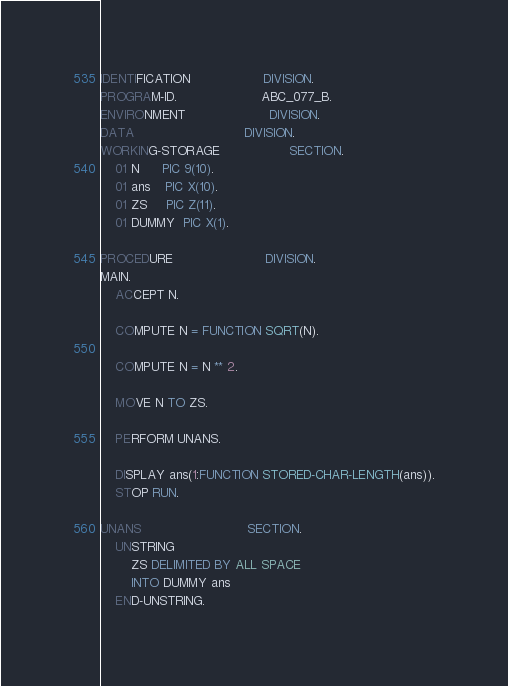<code> <loc_0><loc_0><loc_500><loc_500><_COBOL_>IDENTIFICATION                   DIVISION.
PROGRAM-ID.                      ABC_077_B.
ENVIRONMENT                      DIVISION.
DATA                             DIVISION.
WORKING-STORAGE                  SECTION.
    01 N      PIC 9(10).
    01 ans    PIC X(10).
    01 ZS     PIC Z(11).
    01 DUMMY  PIC X(1).

PROCEDURE                        DIVISION.
MAIN.
    ACCEPT N.

    COMPUTE N = FUNCTION SQRT(N).

    COMPUTE N = N ** 2.

    MOVE N TO ZS.

    PERFORM UNANS.

    DISPLAY ans(1:FUNCTION STORED-CHAR-LENGTH(ans)).
    STOP RUN.

UNANS                            SECTION.
    UNSTRING
        ZS DELIMITED BY ALL SPACE
        INTO DUMMY ans
    END-UNSTRING.
</code> 